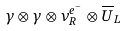Convert formula to latex. <formula><loc_0><loc_0><loc_500><loc_500>\gamma \otimes \gamma \otimes \nu ^ { e ^ { - } } _ { R } \otimes \overline { U } _ { L }</formula> 